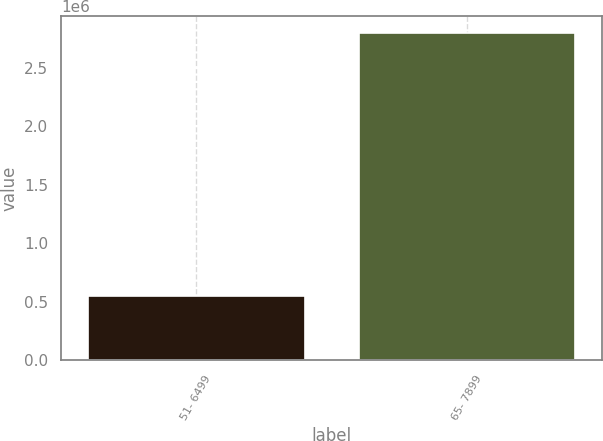<chart> <loc_0><loc_0><loc_500><loc_500><bar_chart><fcel>51- 6499<fcel>65- 7899<nl><fcel>546009<fcel>2.79843e+06<nl></chart> 